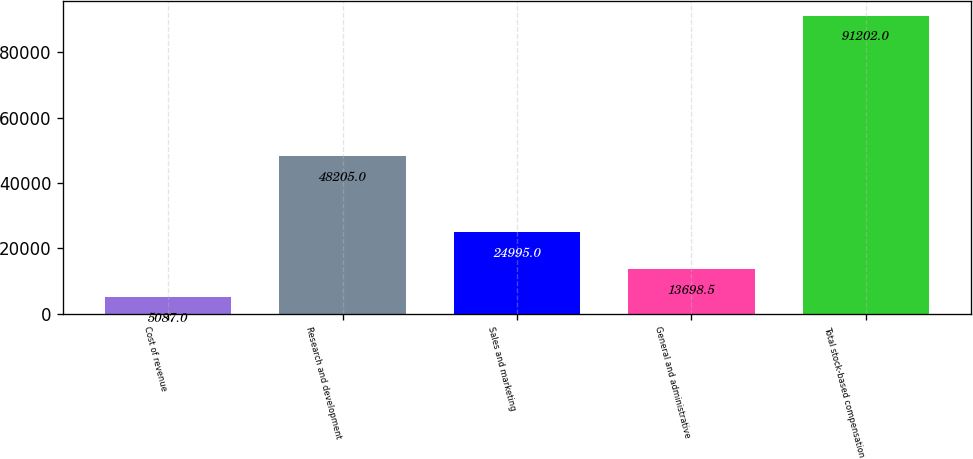Convert chart. <chart><loc_0><loc_0><loc_500><loc_500><bar_chart><fcel>Cost of revenue<fcel>Research and development<fcel>Sales and marketing<fcel>General and administrative<fcel>Total stock-based compensation<nl><fcel>5087<fcel>48205<fcel>24995<fcel>13698.5<fcel>91202<nl></chart> 